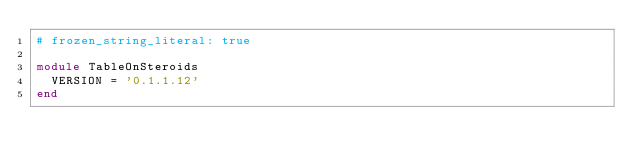Convert code to text. <code><loc_0><loc_0><loc_500><loc_500><_Ruby_># frozen_string_literal: true

module TableOnSteroids
  VERSION = '0.1.1.12'
end
</code> 